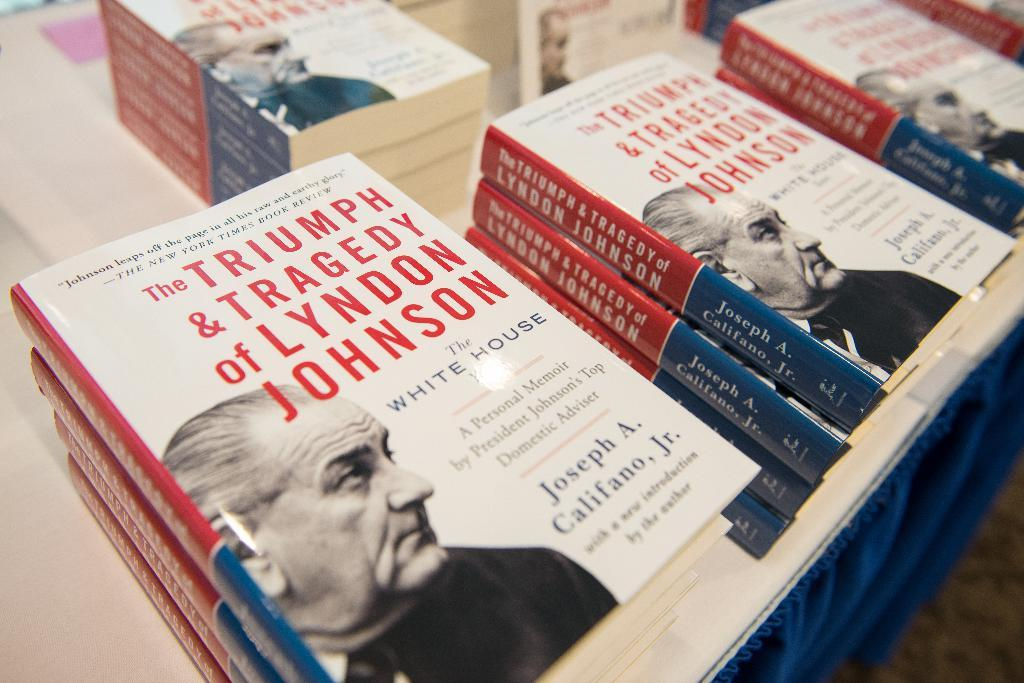<image>
Give a short and clear explanation of the subsequent image. Book by Joseph A Califano, JR. in a store for sale. 